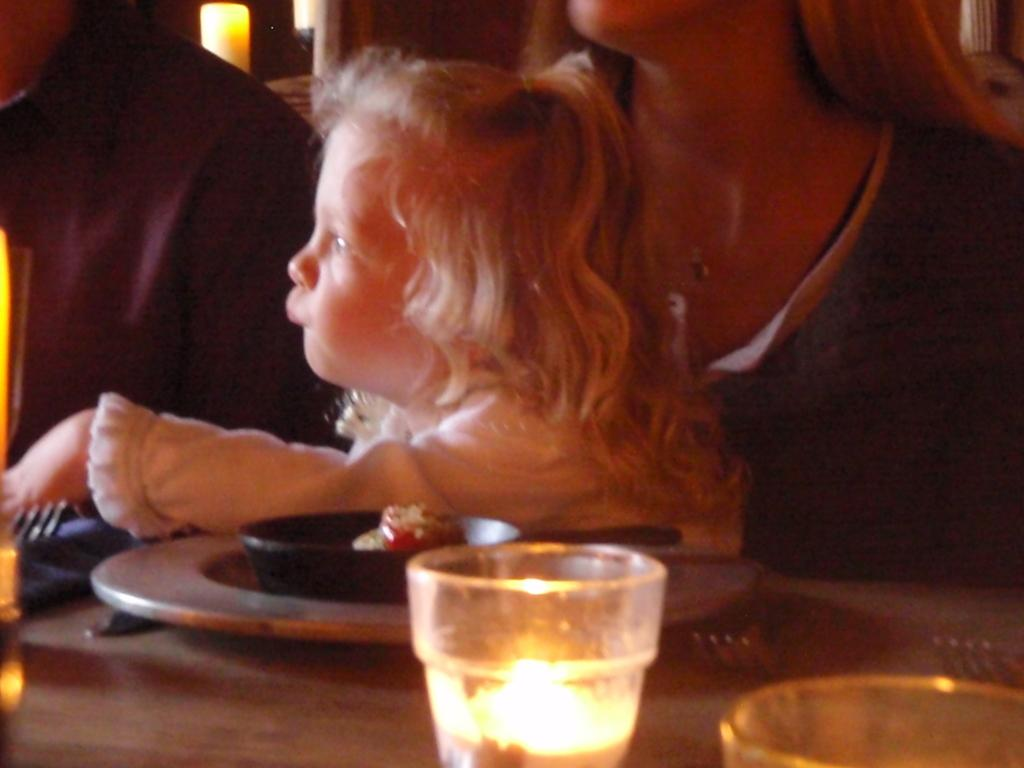How many people are present in the image? There are three persons in the image. What objects are on the table in the image? There is a plate, forks, glasses, and a bowl with food in it on the table. What type of utensils are on the table? There are forks on the table. What is the purpose of the candle in the background of the image? The candle in the background of the image is likely for decoration or ambiance. What type of grain is being cracked by the persons in the image? There is no grain or cracking activity present in the image. 